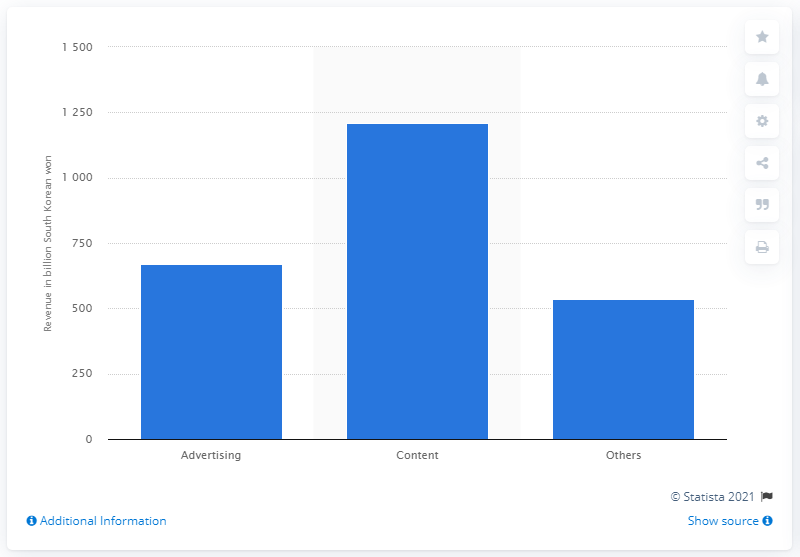Highlight a few significant elements in this photo. In 2018, Kakao's content revenue was approximately 1209.4 won. According to the information available, Kakao's advertising revenue in 2018 was approximately 669.81. 